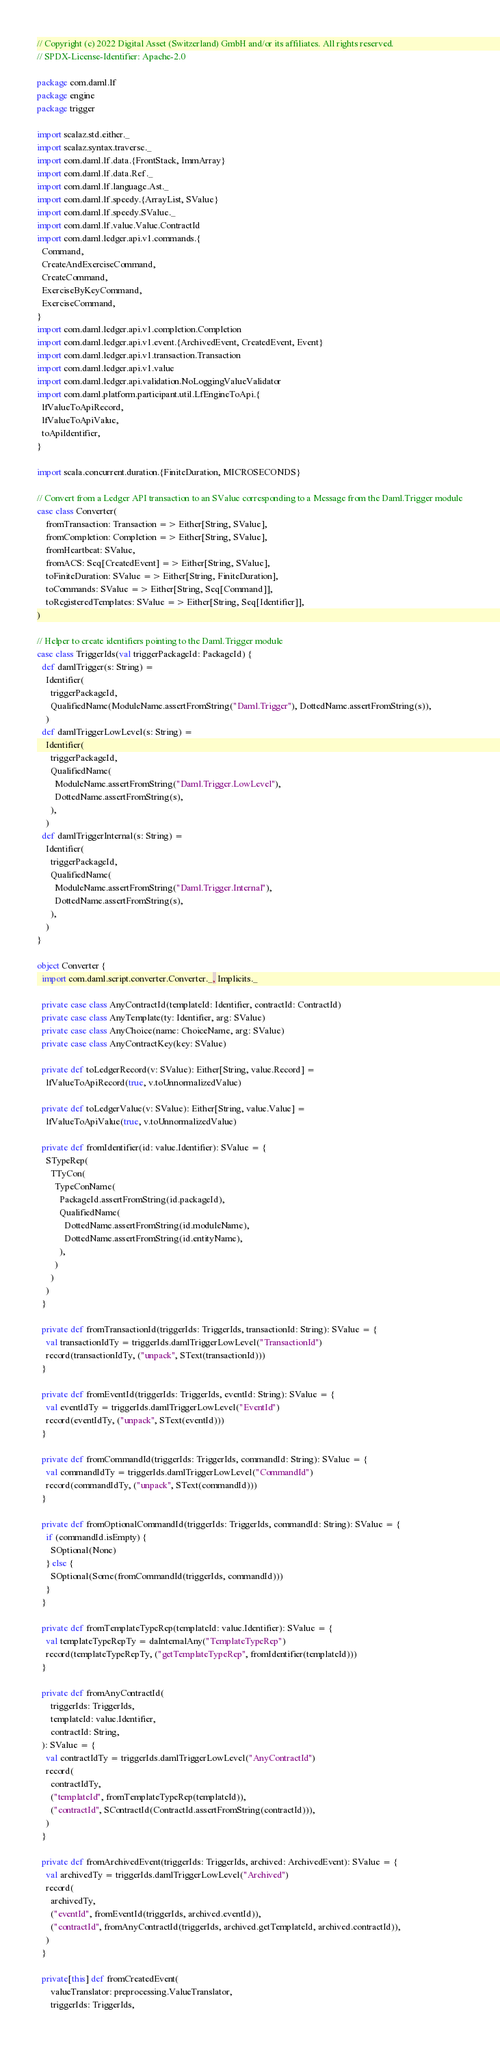Convert code to text. <code><loc_0><loc_0><loc_500><loc_500><_Scala_>// Copyright (c) 2022 Digital Asset (Switzerland) GmbH and/or its affiliates. All rights reserved.
// SPDX-License-Identifier: Apache-2.0

package com.daml.lf
package engine
package trigger

import scalaz.std.either._
import scalaz.syntax.traverse._
import com.daml.lf.data.{FrontStack, ImmArray}
import com.daml.lf.data.Ref._
import com.daml.lf.language.Ast._
import com.daml.lf.speedy.{ArrayList, SValue}
import com.daml.lf.speedy.SValue._
import com.daml.lf.value.Value.ContractId
import com.daml.ledger.api.v1.commands.{
  Command,
  CreateAndExerciseCommand,
  CreateCommand,
  ExerciseByKeyCommand,
  ExerciseCommand,
}
import com.daml.ledger.api.v1.completion.Completion
import com.daml.ledger.api.v1.event.{ArchivedEvent, CreatedEvent, Event}
import com.daml.ledger.api.v1.transaction.Transaction
import com.daml.ledger.api.v1.value
import com.daml.ledger.api.validation.NoLoggingValueValidator
import com.daml.platform.participant.util.LfEngineToApi.{
  lfValueToApiRecord,
  lfValueToApiValue,
  toApiIdentifier,
}

import scala.concurrent.duration.{FiniteDuration, MICROSECONDS}

// Convert from a Ledger API transaction to an SValue corresponding to a Message from the Daml.Trigger module
case class Converter(
    fromTransaction: Transaction => Either[String, SValue],
    fromCompletion: Completion => Either[String, SValue],
    fromHeartbeat: SValue,
    fromACS: Seq[CreatedEvent] => Either[String, SValue],
    toFiniteDuration: SValue => Either[String, FiniteDuration],
    toCommands: SValue => Either[String, Seq[Command]],
    toRegisteredTemplates: SValue => Either[String, Seq[Identifier]],
)

// Helper to create identifiers pointing to the Daml.Trigger module
case class TriggerIds(val triggerPackageId: PackageId) {
  def damlTrigger(s: String) =
    Identifier(
      triggerPackageId,
      QualifiedName(ModuleName.assertFromString("Daml.Trigger"), DottedName.assertFromString(s)),
    )
  def damlTriggerLowLevel(s: String) =
    Identifier(
      triggerPackageId,
      QualifiedName(
        ModuleName.assertFromString("Daml.Trigger.LowLevel"),
        DottedName.assertFromString(s),
      ),
    )
  def damlTriggerInternal(s: String) =
    Identifier(
      triggerPackageId,
      QualifiedName(
        ModuleName.assertFromString("Daml.Trigger.Internal"),
        DottedName.assertFromString(s),
      ),
    )
}

object Converter {
  import com.daml.script.converter.Converter._, Implicits._

  private case class AnyContractId(templateId: Identifier, contractId: ContractId)
  private case class AnyTemplate(ty: Identifier, arg: SValue)
  private case class AnyChoice(name: ChoiceName, arg: SValue)
  private case class AnyContractKey(key: SValue)

  private def toLedgerRecord(v: SValue): Either[String, value.Record] =
    lfValueToApiRecord(true, v.toUnnormalizedValue)

  private def toLedgerValue(v: SValue): Either[String, value.Value] =
    lfValueToApiValue(true, v.toUnnormalizedValue)

  private def fromIdentifier(id: value.Identifier): SValue = {
    STypeRep(
      TTyCon(
        TypeConName(
          PackageId.assertFromString(id.packageId),
          QualifiedName(
            DottedName.assertFromString(id.moduleName),
            DottedName.assertFromString(id.entityName),
          ),
        )
      )
    )
  }

  private def fromTransactionId(triggerIds: TriggerIds, transactionId: String): SValue = {
    val transactionIdTy = triggerIds.damlTriggerLowLevel("TransactionId")
    record(transactionIdTy, ("unpack", SText(transactionId)))
  }

  private def fromEventId(triggerIds: TriggerIds, eventId: String): SValue = {
    val eventIdTy = triggerIds.damlTriggerLowLevel("EventId")
    record(eventIdTy, ("unpack", SText(eventId)))
  }

  private def fromCommandId(triggerIds: TriggerIds, commandId: String): SValue = {
    val commandIdTy = triggerIds.damlTriggerLowLevel("CommandId")
    record(commandIdTy, ("unpack", SText(commandId)))
  }

  private def fromOptionalCommandId(triggerIds: TriggerIds, commandId: String): SValue = {
    if (commandId.isEmpty) {
      SOptional(None)
    } else {
      SOptional(Some(fromCommandId(triggerIds, commandId)))
    }
  }

  private def fromTemplateTypeRep(templateId: value.Identifier): SValue = {
    val templateTypeRepTy = daInternalAny("TemplateTypeRep")
    record(templateTypeRepTy, ("getTemplateTypeRep", fromIdentifier(templateId)))
  }

  private def fromAnyContractId(
      triggerIds: TriggerIds,
      templateId: value.Identifier,
      contractId: String,
  ): SValue = {
    val contractIdTy = triggerIds.damlTriggerLowLevel("AnyContractId")
    record(
      contractIdTy,
      ("templateId", fromTemplateTypeRep(templateId)),
      ("contractId", SContractId(ContractId.assertFromString(contractId))),
    )
  }

  private def fromArchivedEvent(triggerIds: TriggerIds, archived: ArchivedEvent): SValue = {
    val archivedTy = triggerIds.damlTriggerLowLevel("Archived")
    record(
      archivedTy,
      ("eventId", fromEventId(triggerIds, archived.eventId)),
      ("contractId", fromAnyContractId(triggerIds, archived.getTemplateId, archived.contractId)),
    )
  }

  private[this] def fromCreatedEvent(
      valueTranslator: preprocessing.ValueTranslator,
      triggerIds: TriggerIds,</code> 